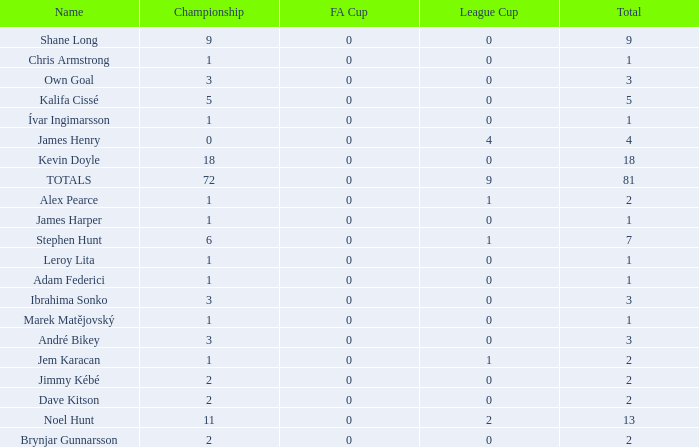What is the total championships of James Henry that has a league cup more than 1? 0.0. 